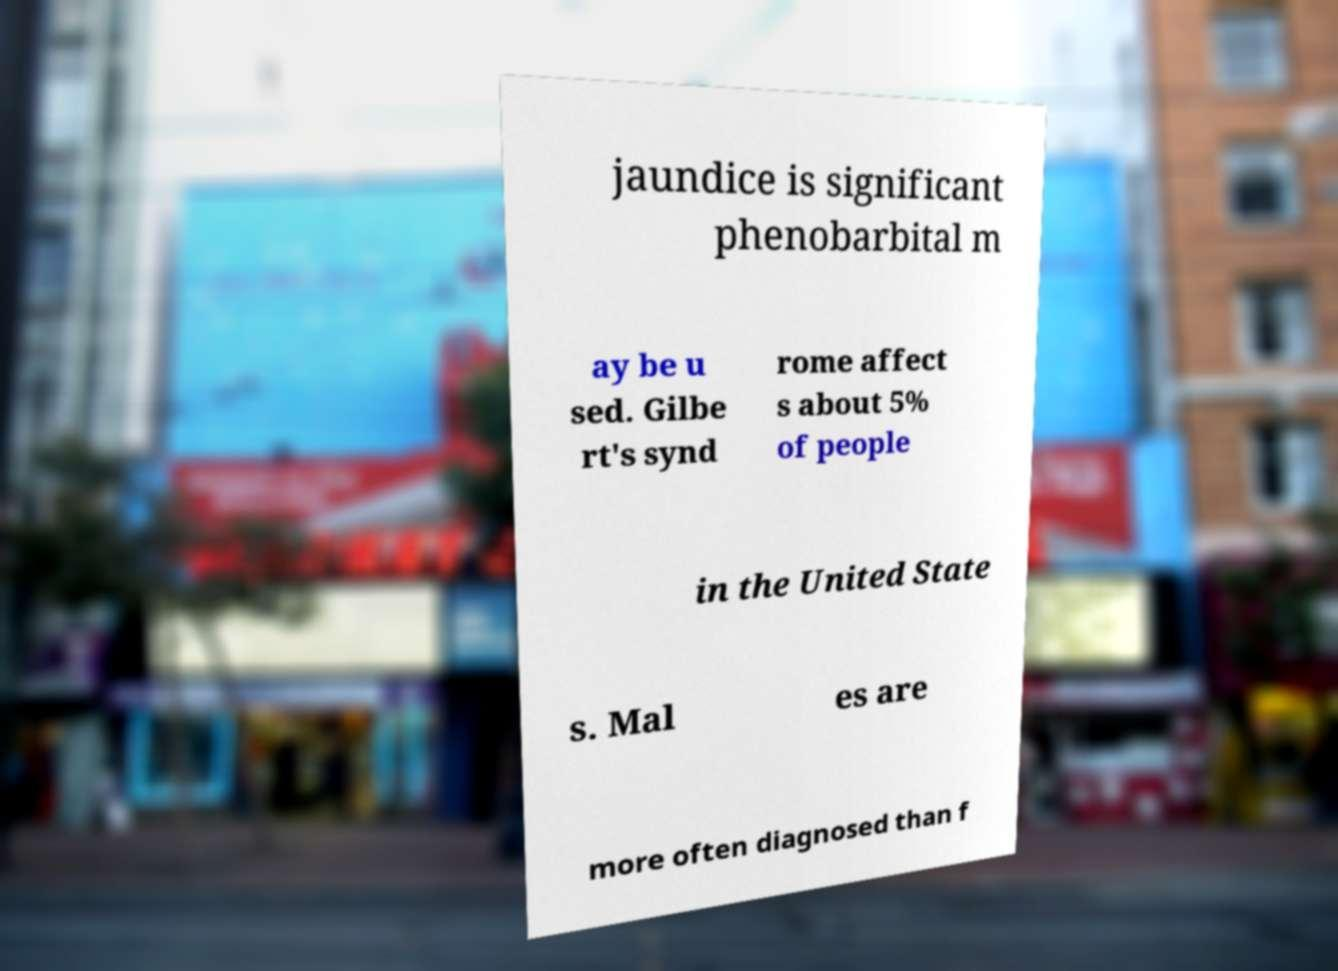Could you extract and type out the text from this image? jaundice is significant phenobarbital m ay be u sed. Gilbe rt's synd rome affect s about 5% of people in the United State s. Mal es are more often diagnosed than f 